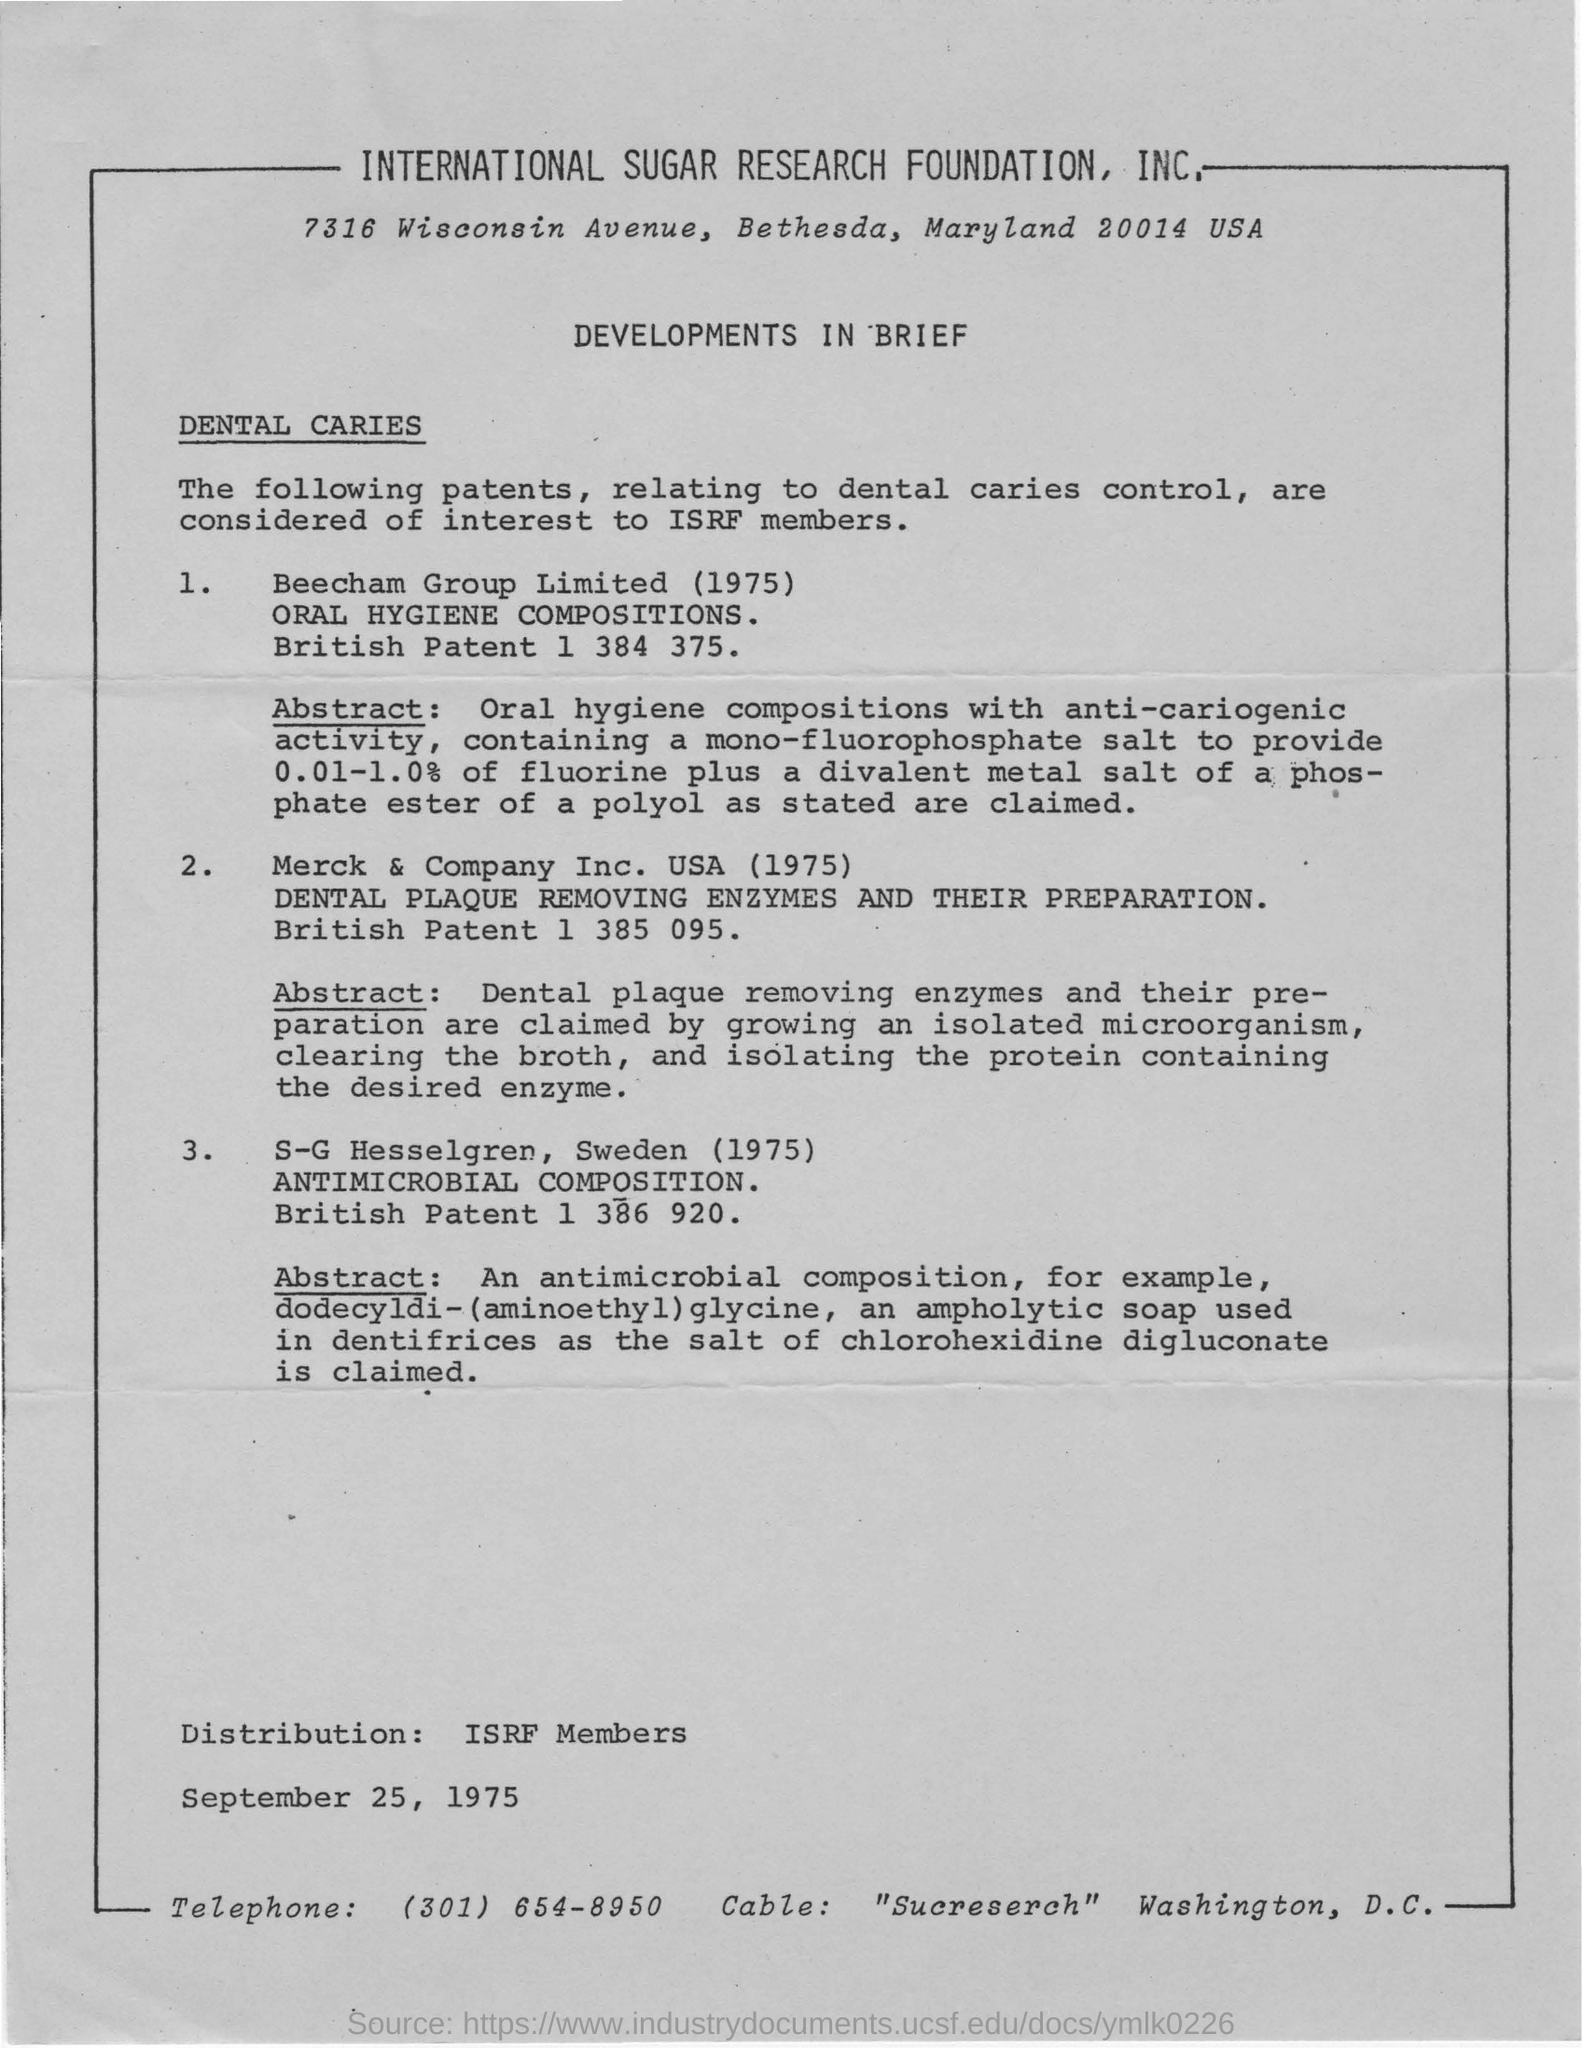What is the short from of International Sugar Research Foundation?
Your answer should be compact. Isrf. In which year merck & company inc. USA started?
Ensure brevity in your answer.  1975. 